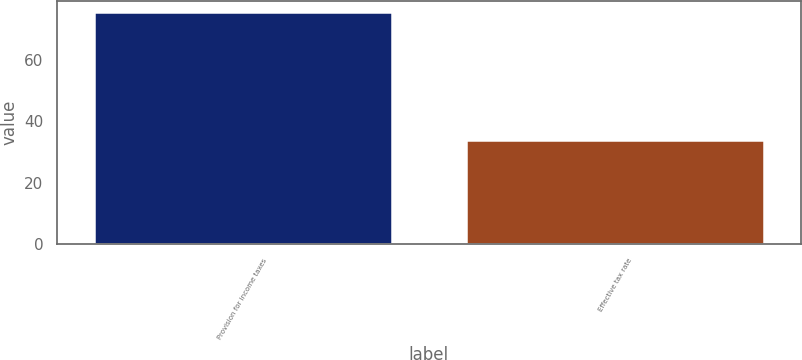<chart> <loc_0><loc_0><loc_500><loc_500><bar_chart><fcel>Provision for income taxes<fcel>Effective tax rate<nl><fcel>75.3<fcel>33.7<nl></chart> 